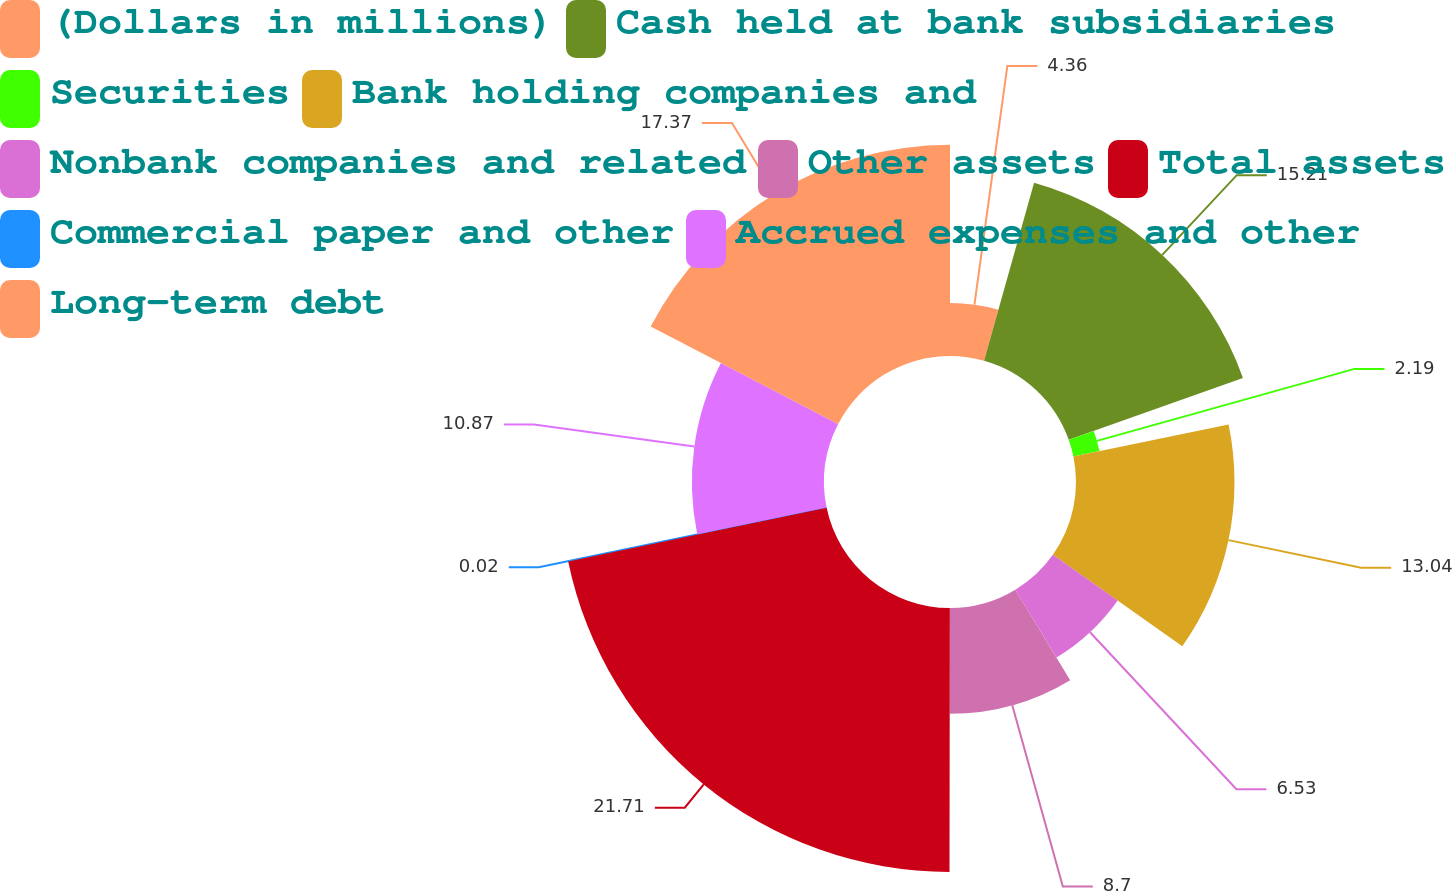Convert chart. <chart><loc_0><loc_0><loc_500><loc_500><pie_chart><fcel>(Dollars in millions)<fcel>Cash held at bank subsidiaries<fcel>Securities<fcel>Bank holding companies and<fcel>Nonbank companies and related<fcel>Other assets<fcel>Total assets<fcel>Commercial paper and other<fcel>Accrued expenses and other<fcel>Long-term debt<nl><fcel>4.36%<fcel>15.21%<fcel>2.19%<fcel>13.04%<fcel>6.53%<fcel>8.7%<fcel>21.72%<fcel>0.02%<fcel>10.87%<fcel>17.38%<nl></chart> 